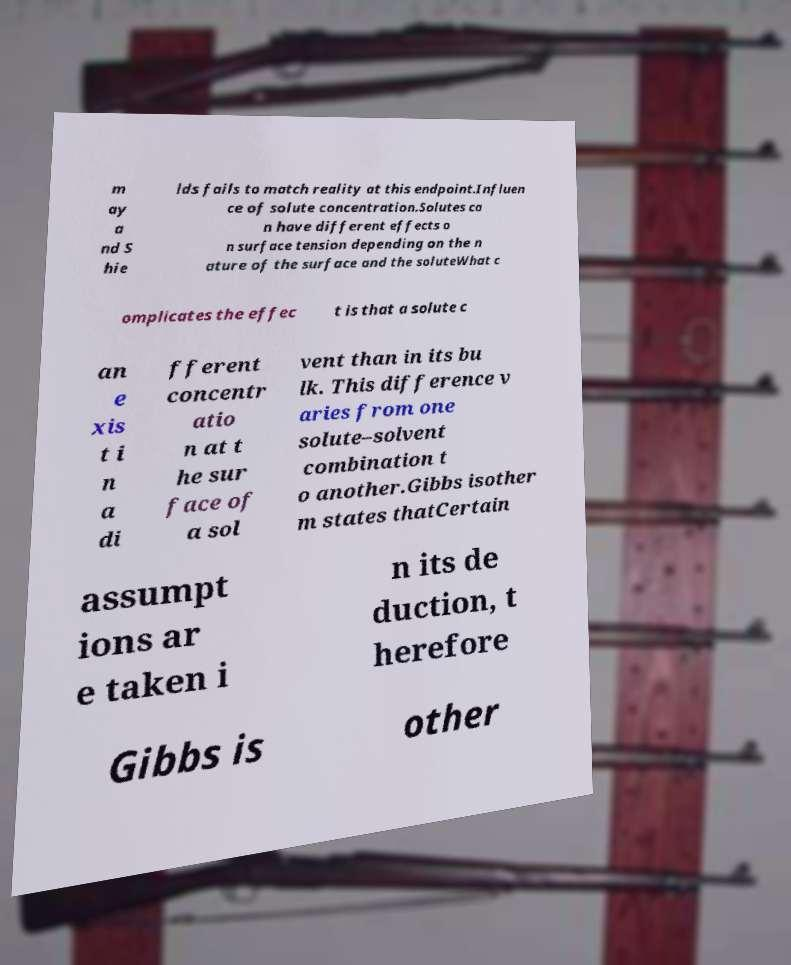Please identify and transcribe the text found in this image. m ay a nd S hie lds fails to match reality at this endpoint.Influen ce of solute concentration.Solutes ca n have different effects o n surface tension depending on the n ature of the surface and the soluteWhat c omplicates the effec t is that a solute c an e xis t i n a di fferent concentr atio n at t he sur face of a sol vent than in its bu lk. This difference v aries from one solute–solvent combination t o another.Gibbs isother m states thatCertain assumpt ions ar e taken i n its de duction, t herefore Gibbs is other 